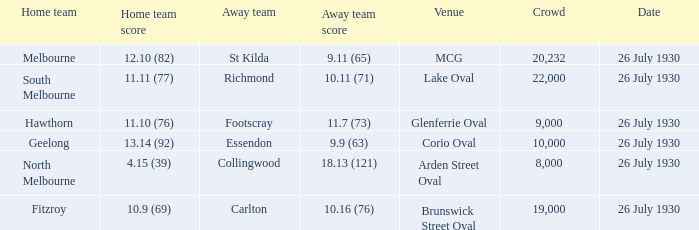When was Fitzroy the home team? 26 July 1930. 